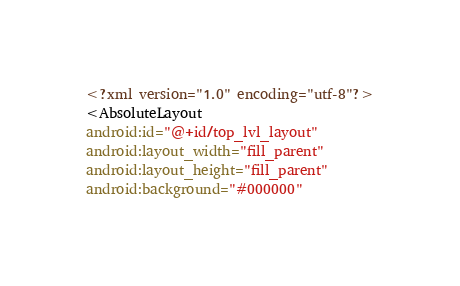Convert code to text. <code><loc_0><loc_0><loc_500><loc_500><_XML_><?xml version="1.0" encoding="utf-8"?>
<AbsoluteLayout
android:id="@+id/top_lvl_layout"
android:layout_width="fill_parent"
android:layout_height="fill_parent"
android:background="#000000"</code> 